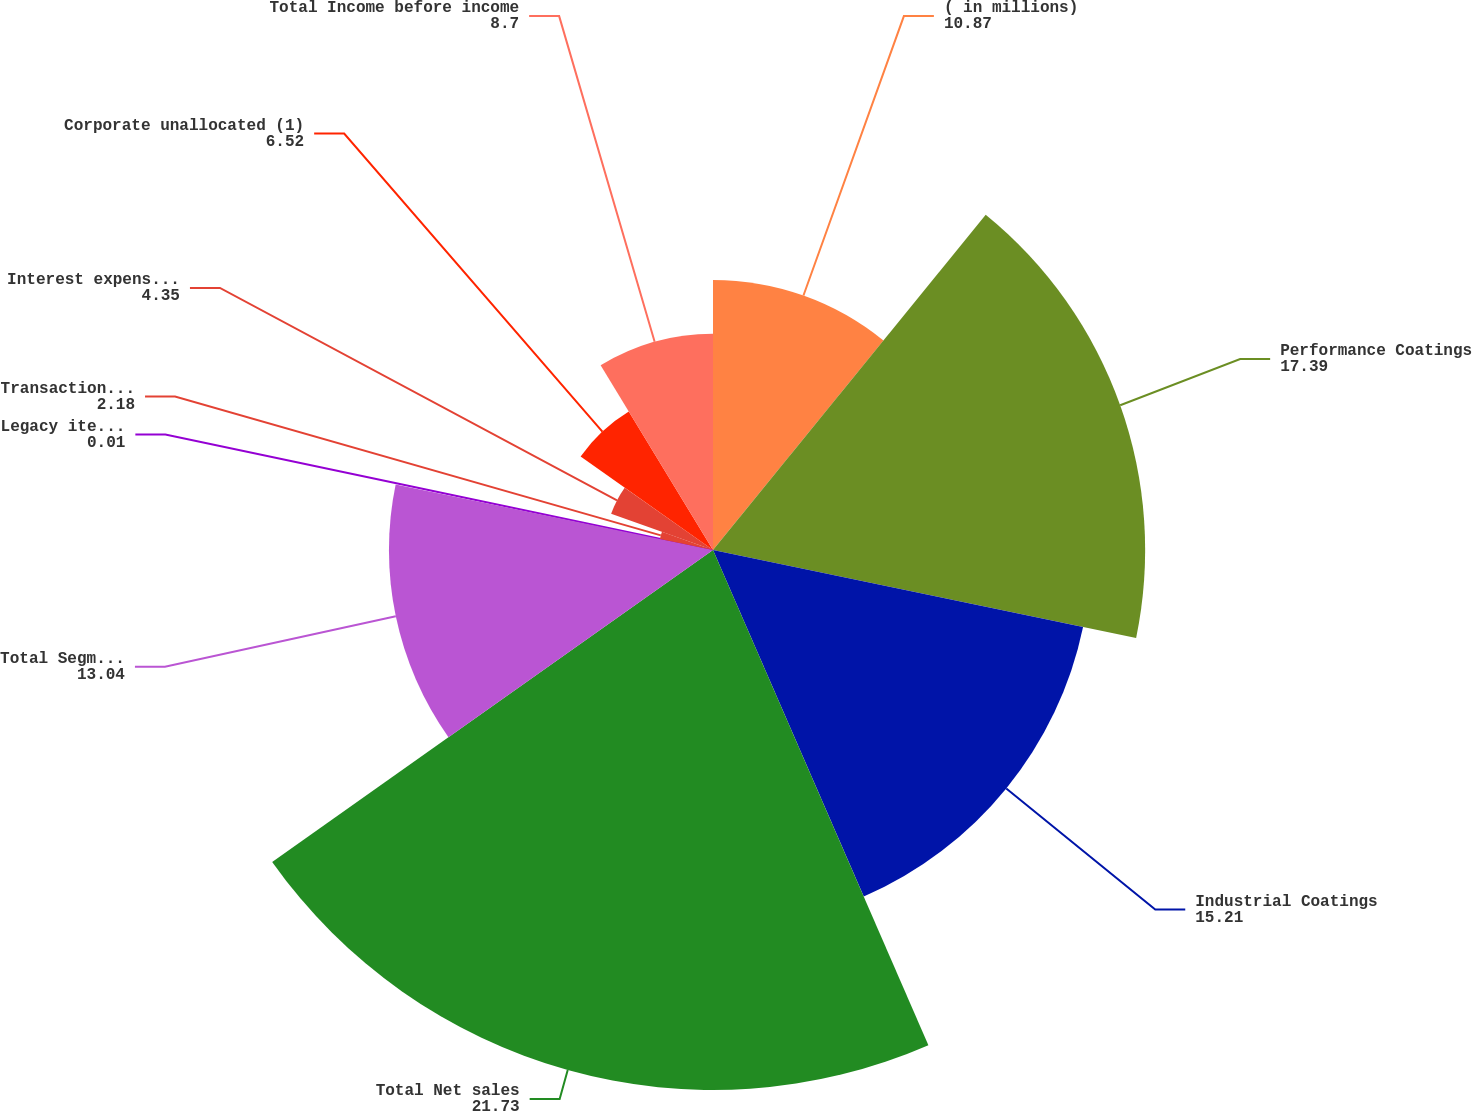Convert chart to OTSL. <chart><loc_0><loc_0><loc_500><loc_500><pie_chart><fcel>( in millions)<fcel>Performance Coatings<fcel>Industrial Coatings<fcel>Total Net sales<fcel>Total Segment income<fcel>Legacy items (2)<fcel>Transaction-related costs (3)<fcel>Interest expense net of<fcel>Corporate unallocated (1)<fcel>Total Income before income<nl><fcel>10.87%<fcel>17.39%<fcel>15.21%<fcel>21.73%<fcel>13.04%<fcel>0.01%<fcel>2.18%<fcel>4.35%<fcel>6.52%<fcel>8.7%<nl></chart> 